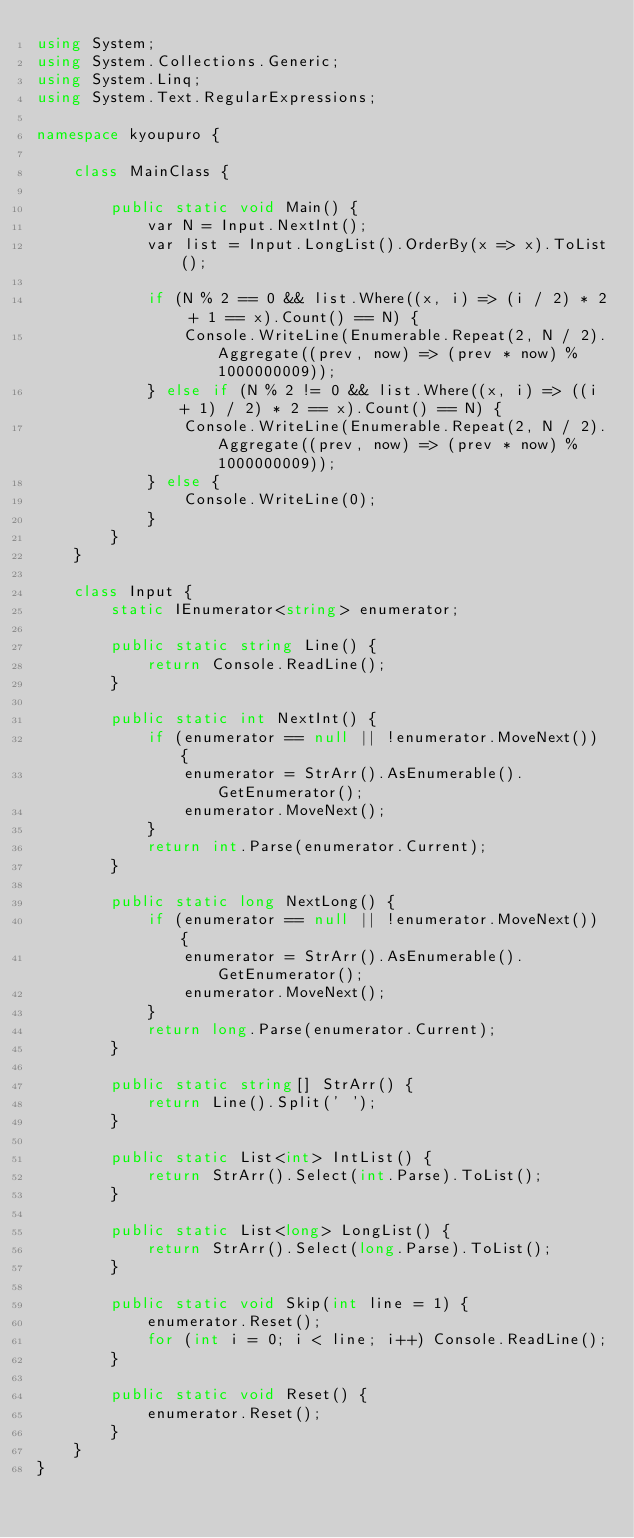Convert code to text. <code><loc_0><loc_0><loc_500><loc_500><_C#_>using System;
using System.Collections.Generic;
using System.Linq;
using System.Text.RegularExpressions;

namespace kyoupuro {

    class MainClass {

        public static void Main() {
            var N = Input.NextInt();
            var list = Input.LongList().OrderBy(x => x).ToList();

            if (N % 2 == 0 && list.Where((x, i) => (i / 2) * 2 + 1 == x).Count() == N) {
                Console.WriteLine(Enumerable.Repeat(2, N / 2).Aggregate((prev, now) => (prev * now) % 1000000009));
            } else if (N % 2 != 0 && list.Where((x, i) => ((i + 1) / 2) * 2 == x).Count() == N) {
                Console.WriteLine(Enumerable.Repeat(2, N / 2).Aggregate((prev, now) => (prev * now) % 1000000009));
            } else {
                Console.WriteLine(0);
            }
        }
    }

    class Input {
        static IEnumerator<string> enumerator;

        public static string Line() {
            return Console.ReadLine();
        }

        public static int NextInt() {
            if (enumerator == null || !enumerator.MoveNext()) {
                enumerator = StrArr().AsEnumerable().GetEnumerator();
                enumerator.MoveNext();
            }
            return int.Parse(enumerator.Current);
        }

        public static long NextLong() {
            if (enumerator == null || !enumerator.MoveNext()) {
                enumerator = StrArr().AsEnumerable().GetEnumerator();
                enumerator.MoveNext();
            }
            return long.Parse(enumerator.Current);
        }

        public static string[] StrArr() {
            return Line().Split(' ');
        }

        public static List<int> IntList() {
            return StrArr().Select(int.Parse).ToList();
        }

        public static List<long> LongList() {
            return StrArr().Select(long.Parse).ToList();
        }

        public static void Skip(int line = 1) {
            enumerator.Reset();
            for (int i = 0; i < line; i++) Console.ReadLine();
        }

        public static void Reset() {
            enumerator.Reset();
        }
    }
}</code> 